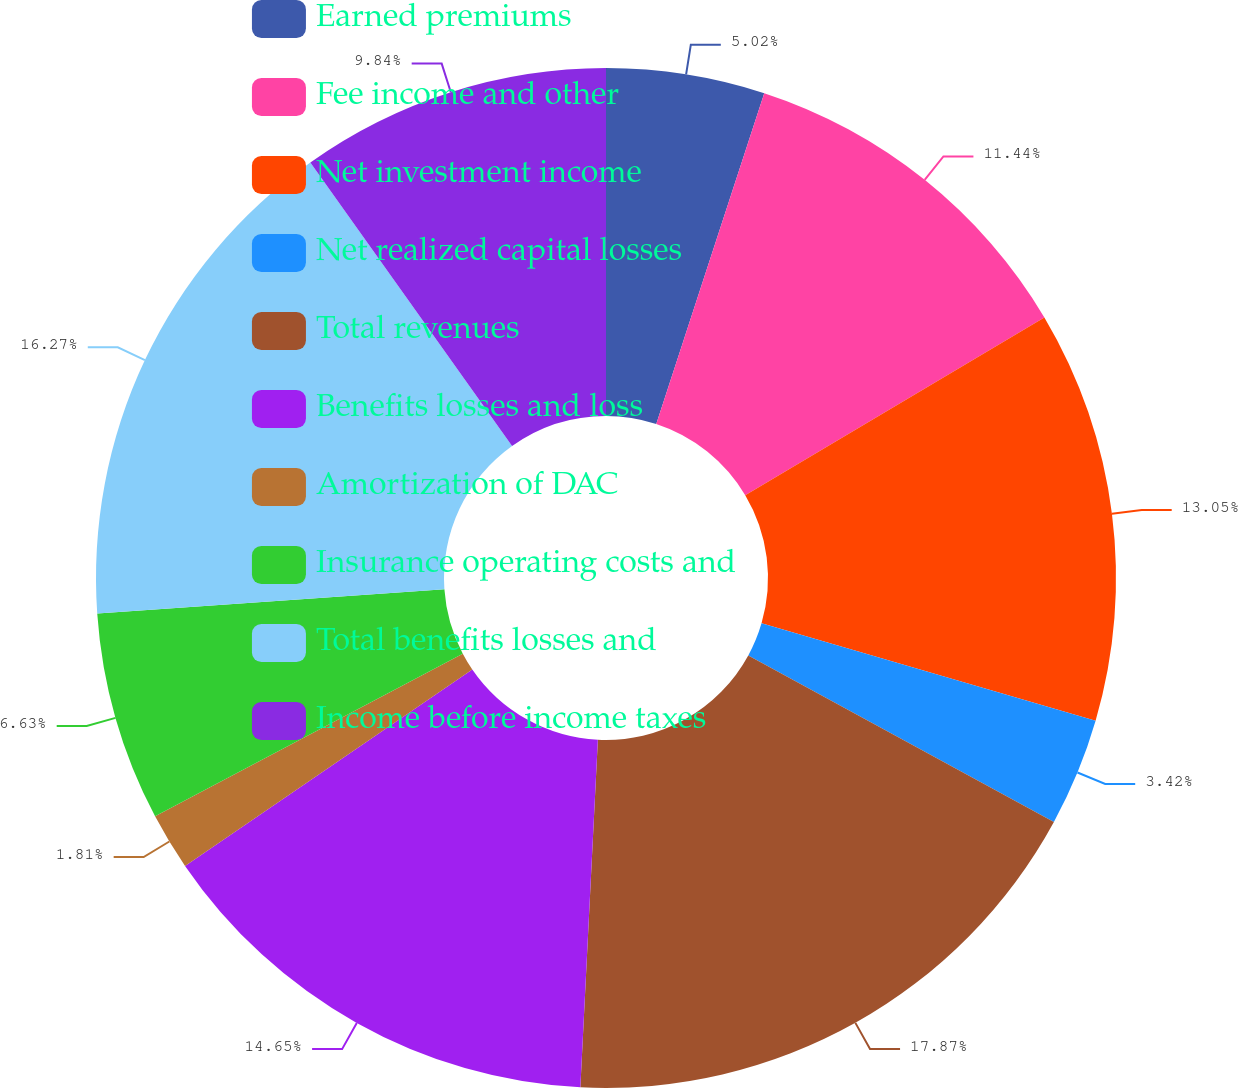<chart> <loc_0><loc_0><loc_500><loc_500><pie_chart><fcel>Earned premiums<fcel>Fee income and other<fcel>Net investment income<fcel>Net realized capital losses<fcel>Total revenues<fcel>Benefits losses and loss<fcel>Amortization of DAC<fcel>Insurance operating costs and<fcel>Total benefits losses and<fcel>Income before income taxes<nl><fcel>5.02%<fcel>11.44%<fcel>13.05%<fcel>3.42%<fcel>17.86%<fcel>14.65%<fcel>1.81%<fcel>6.63%<fcel>16.26%<fcel>9.84%<nl></chart> 